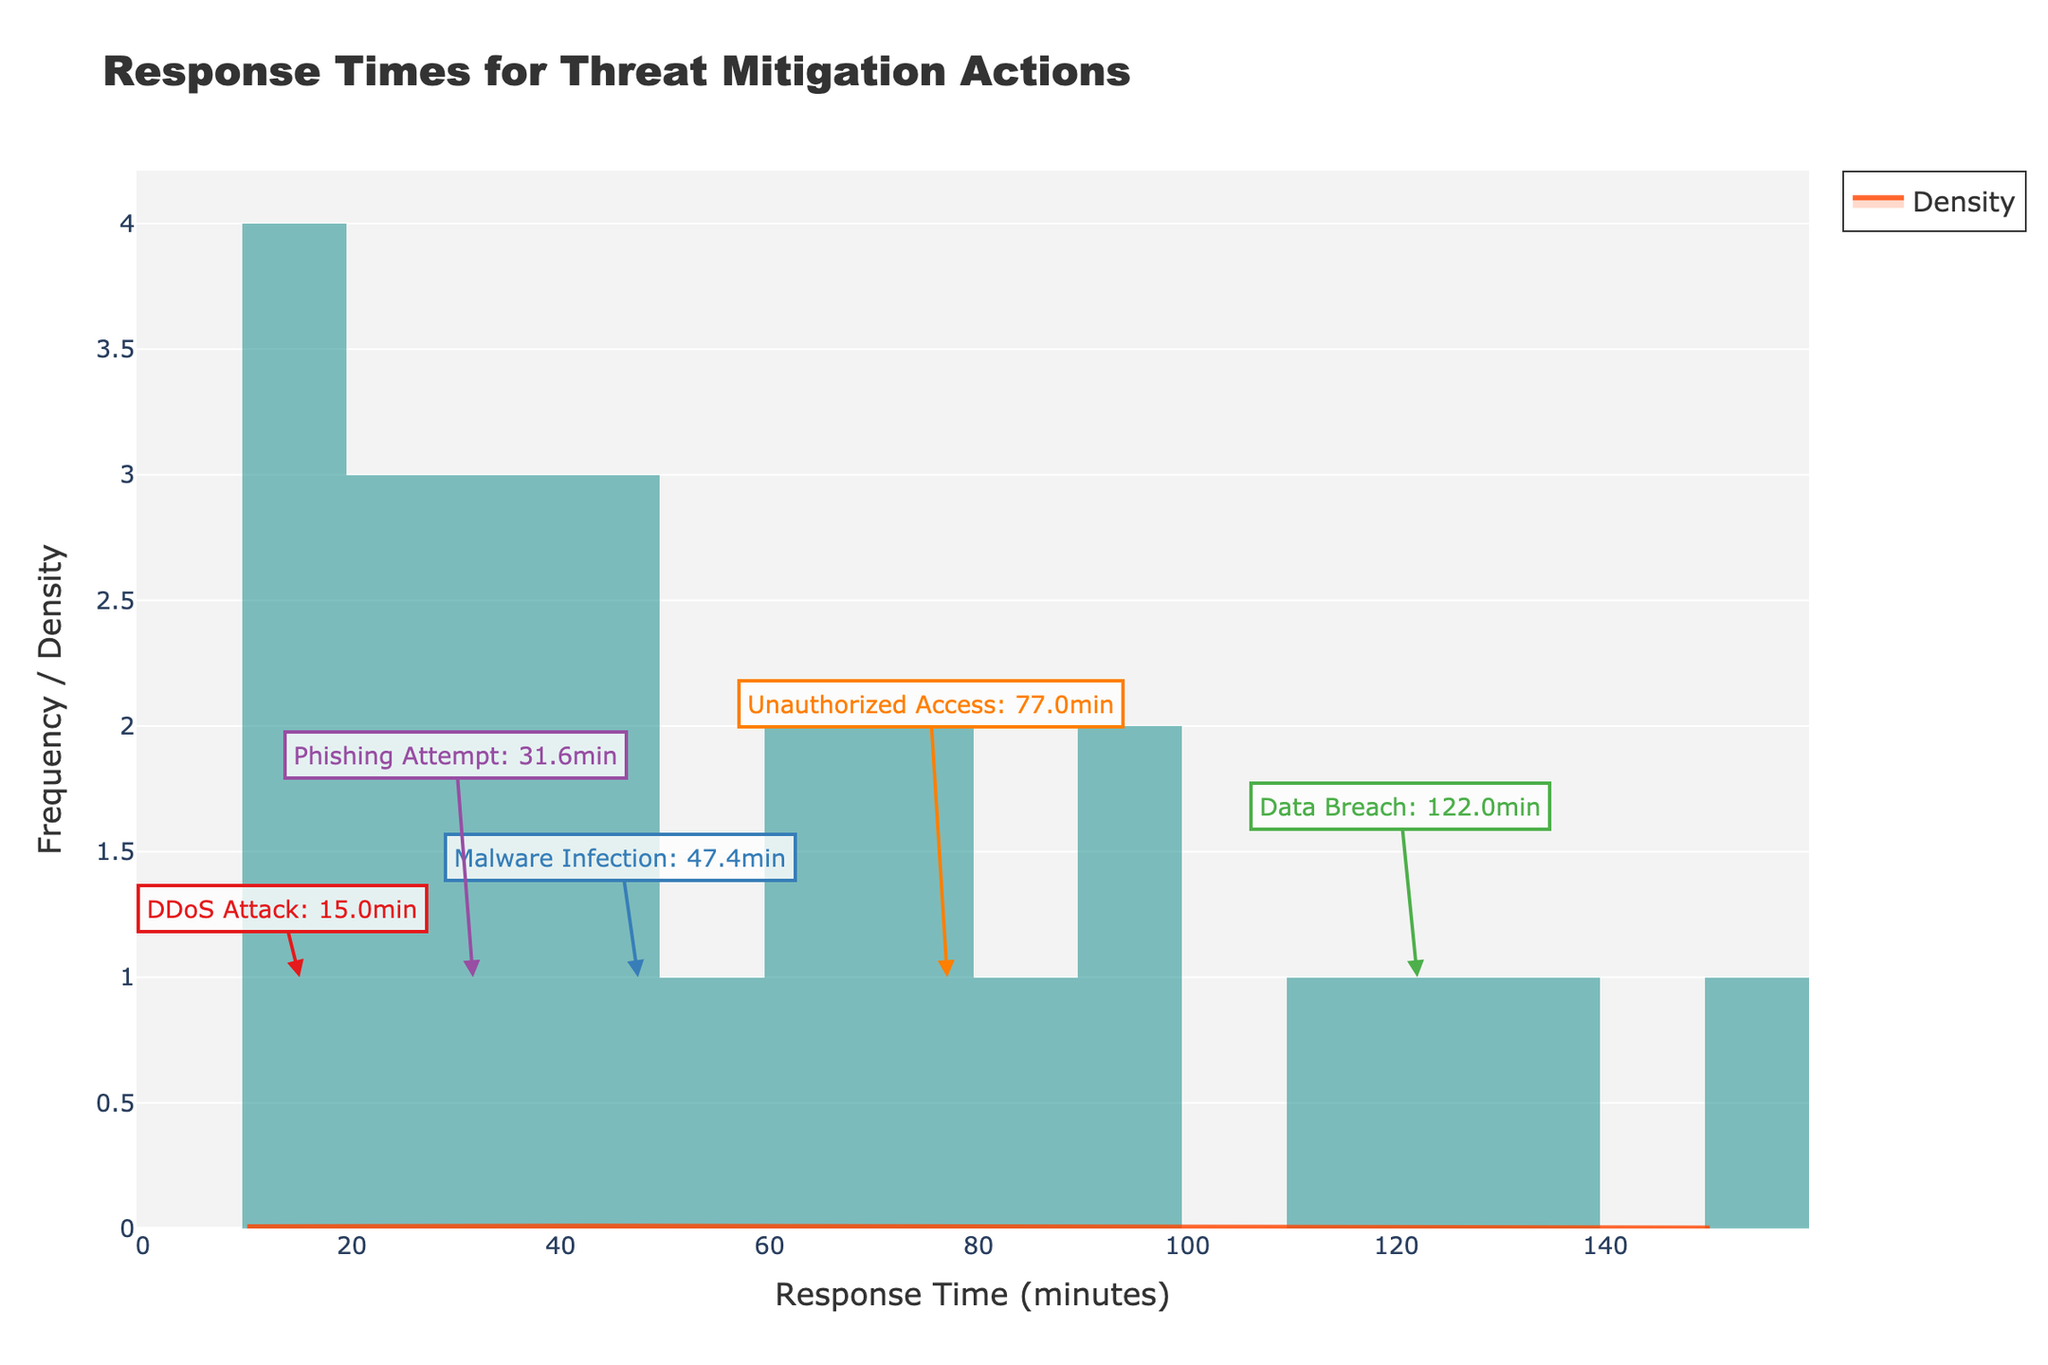What is the title of the figure? The title is located at the top center of the figure and is in a larger, bold font for emphasis.
Answer: Response Times for Threat Mitigation Actions What are the units on the x-axis? The x-axis title is displayed just below the axis and indicates the units being measured.
Answer: Response Time (minutes) How many bins are there in the histogram? The histogram has vertical bars that represent the frequency of response times divided into bins, which can be counted directly from the figure.
Answer: 20 Which incident type has the lowest average response time? The figure includes color-coded annotations for each incident type, showing their average response times; the one with the smallest value is the answer.
Answer: DDoS Attack How high is the KDE peak? The KDE curve's highest point represents the maximum density value; this can be determined by observing its peak.
Answer: 0.025 (approximate based on figure) What is the average response time for a Data Breach incident? The annotation for "Data Breach" shows its average response time, making it straightforward to find.
Answer: 122 minutes How do the response times for Malware Infections compare to those for Data Breaches? Comparing the positions and shapes of the histogram bars and KDE curves for both incidents will show that Malware Infections generally have lower response times compared to Data Breaches.
Answer: Malware Infections are shorter What is the median response time? The median response time is the midpoint of the ordered data set, and visually, it can be inferred from the approximate center of the data spread in the histogram.
Answer: Around 60 minutes Which incident type has the most variation in response times? Observing the spread and range of the histogram bars, along with the width of the KDE curve for each incident type, will reveal which one has the highest variation.
Answer: Data Breach What is the most frequent response time for threat mitigation actions? The histogram peak represents the most frequent response time, identifiable by the tallest bar in the histogram.
Answer: 30 minutes 